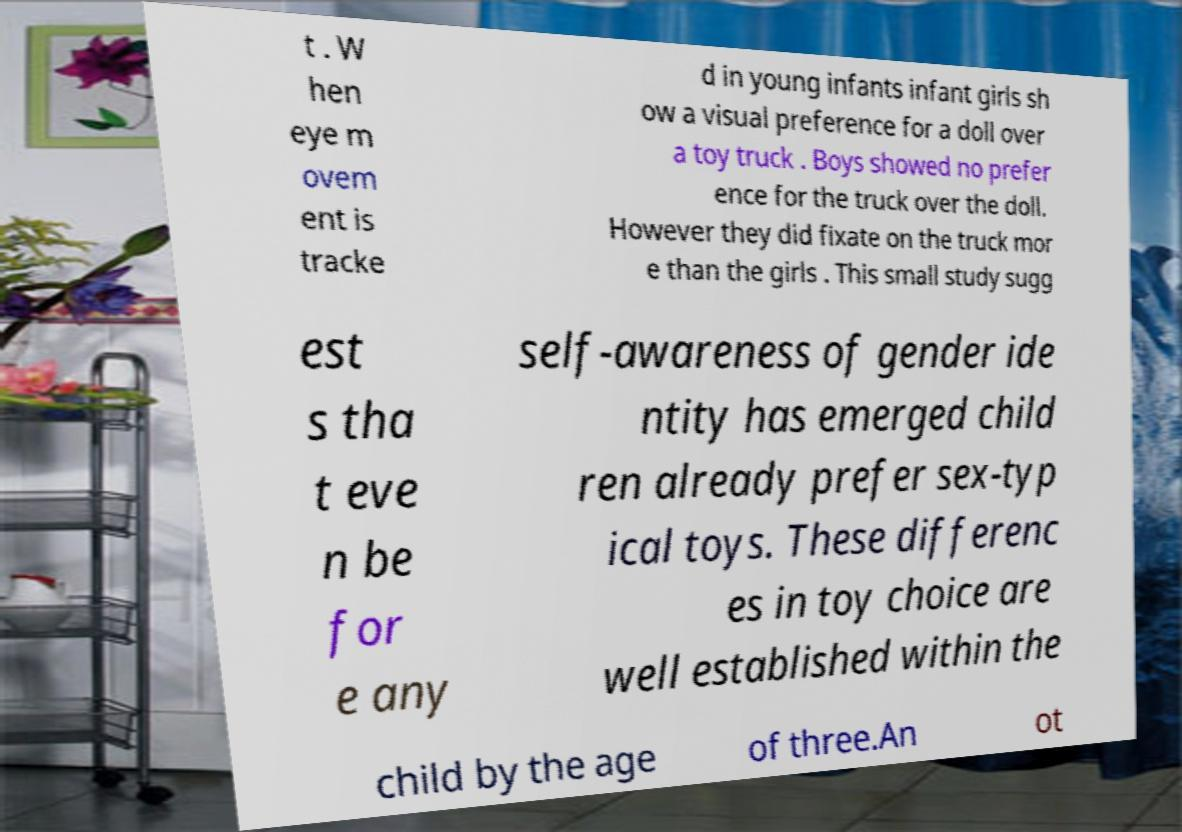For documentation purposes, I need the text within this image transcribed. Could you provide that? t . W hen eye m ovem ent is tracke d in young infants infant girls sh ow a visual preference for a doll over a toy truck . Boys showed no prefer ence for the truck over the doll. However they did fixate on the truck mor e than the girls . This small study sugg est s tha t eve n be for e any self-awareness of gender ide ntity has emerged child ren already prefer sex-typ ical toys. These differenc es in toy choice are well established within the child by the age of three.An ot 